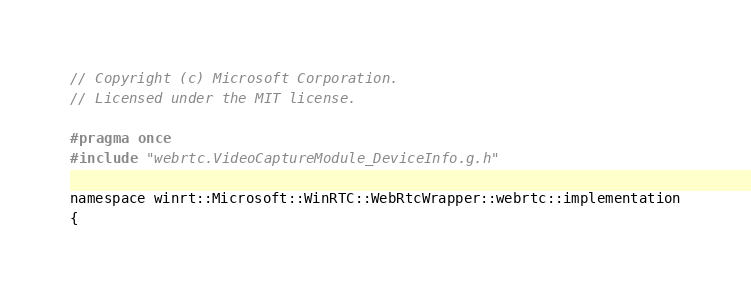Convert code to text. <code><loc_0><loc_0><loc_500><loc_500><_C_>// Copyright (c) Microsoft Corporation.
// Licensed under the MIT license.

#pragma once
#include "webrtc.VideoCaptureModule_DeviceInfo.g.h"

namespace winrt::Microsoft::WinRTC::WebRtcWrapper::webrtc::implementation
{</code> 